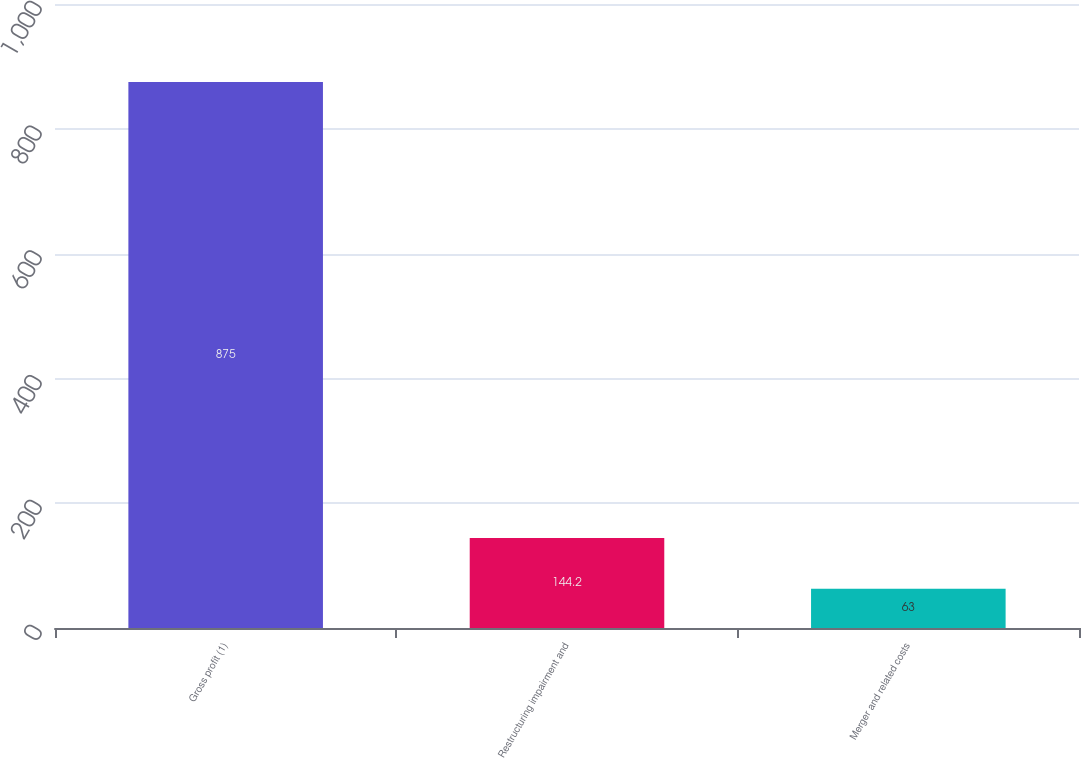<chart> <loc_0><loc_0><loc_500><loc_500><bar_chart><fcel>Gross profit (1)<fcel>Restructuring impairment and<fcel>Merger and related costs<nl><fcel>875<fcel>144.2<fcel>63<nl></chart> 